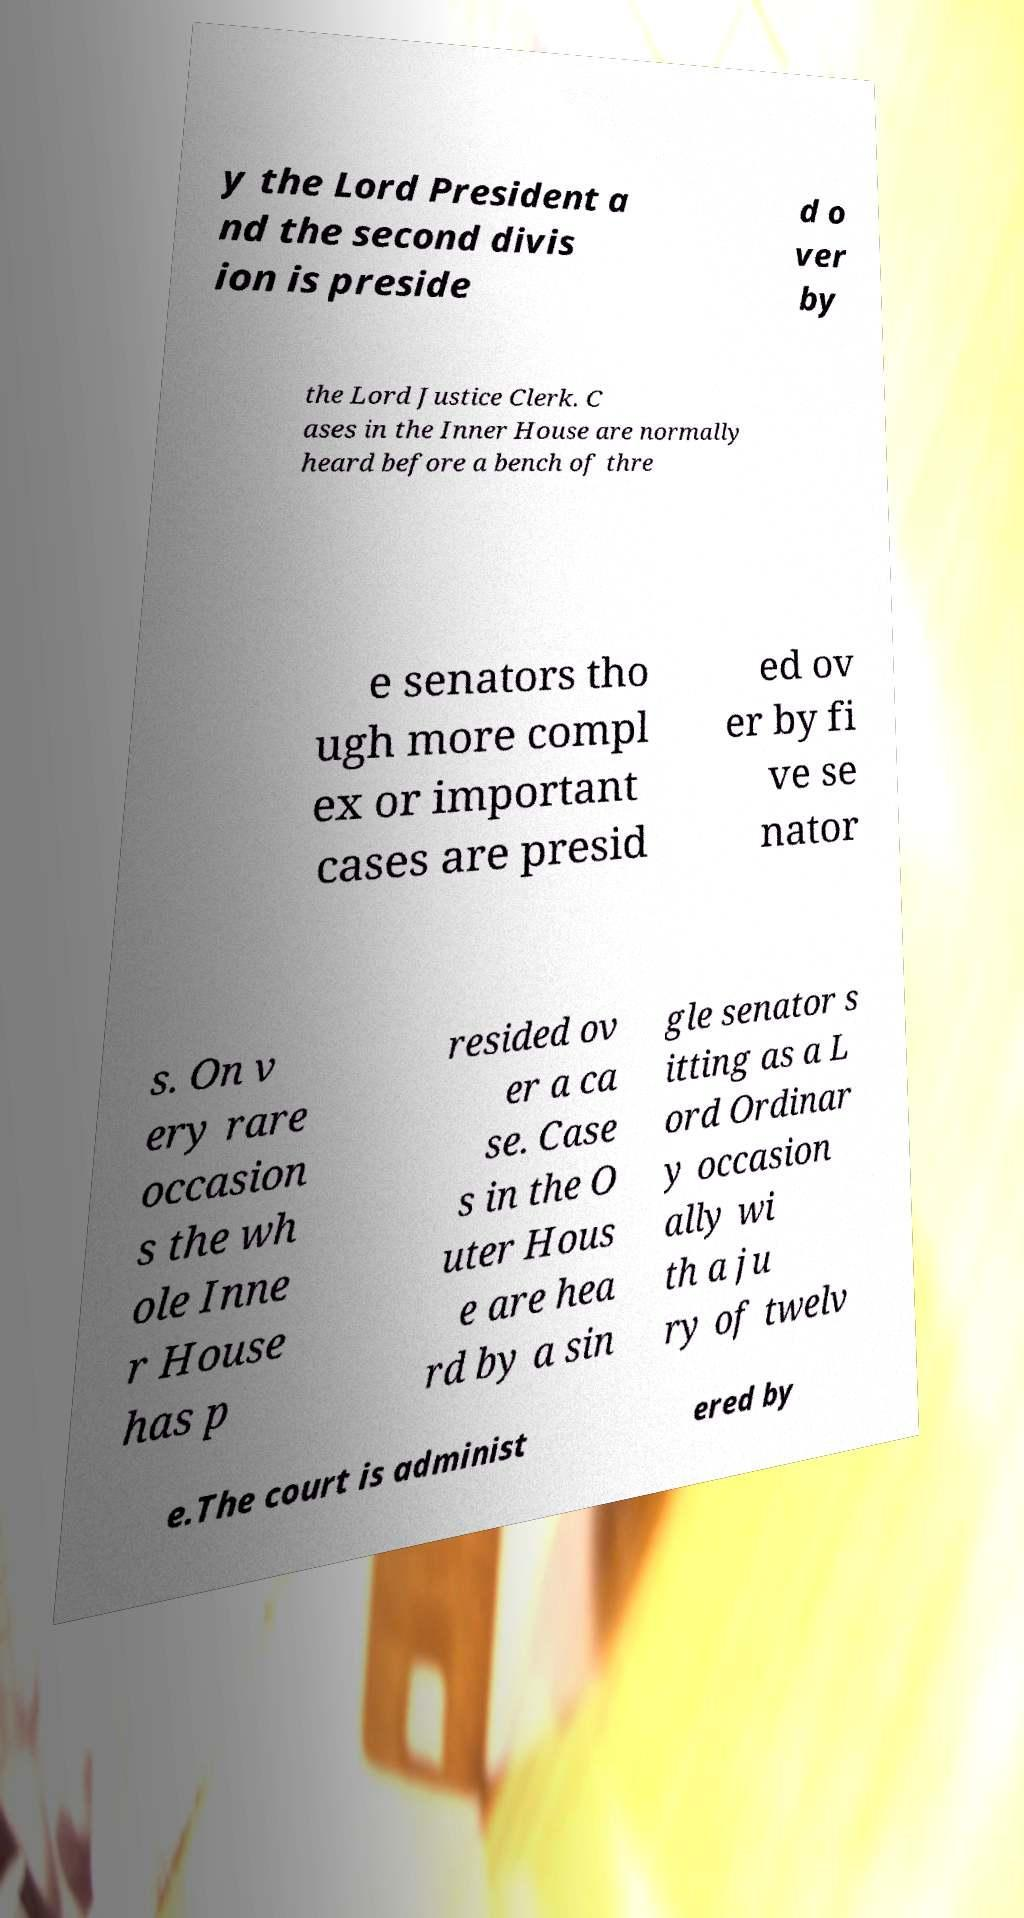Could you assist in decoding the text presented in this image and type it out clearly? y the Lord President a nd the second divis ion is preside d o ver by the Lord Justice Clerk. C ases in the Inner House are normally heard before a bench of thre e senators tho ugh more compl ex or important cases are presid ed ov er by fi ve se nator s. On v ery rare occasion s the wh ole Inne r House has p resided ov er a ca se. Case s in the O uter Hous e are hea rd by a sin gle senator s itting as a L ord Ordinar y occasion ally wi th a ju ry of twelv e.The court is administ ered by 